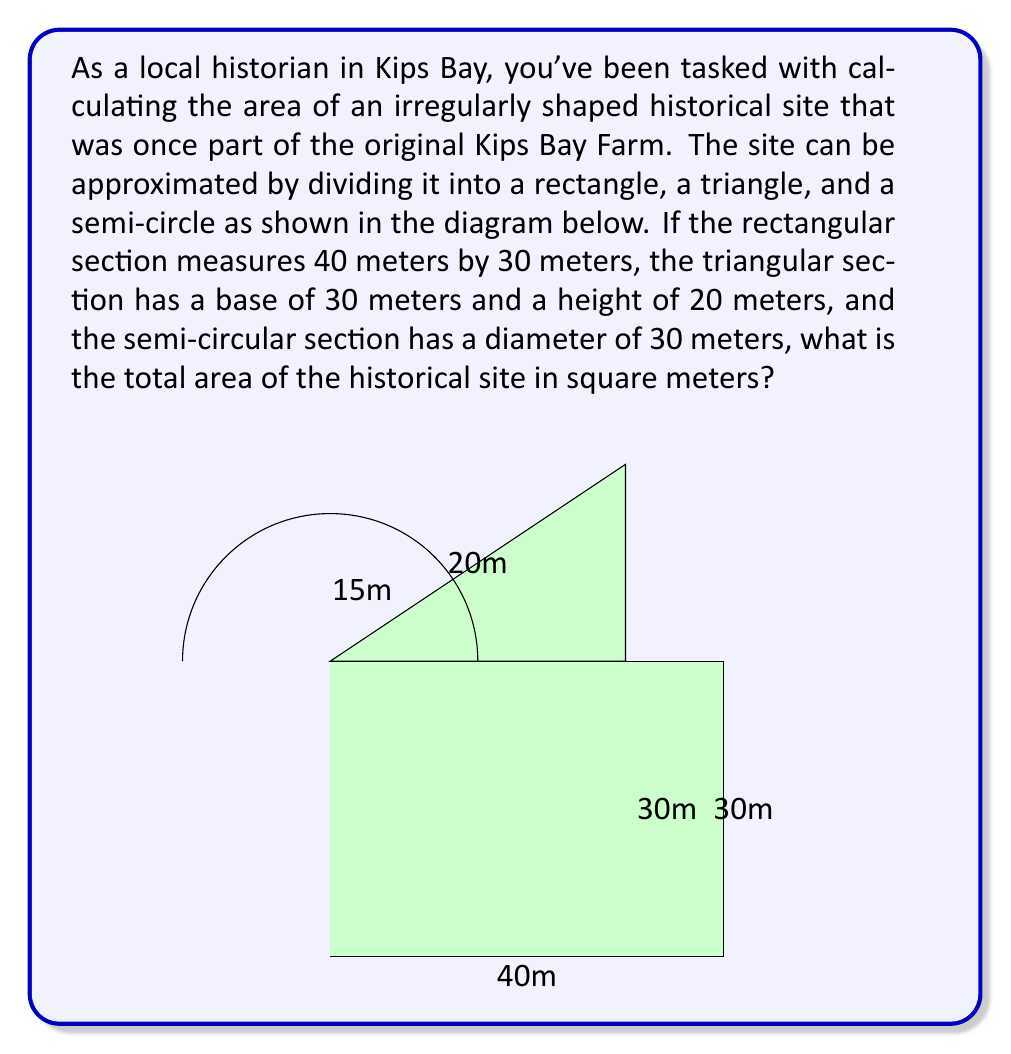What is the answer to this math problem? To solve this problem, we need to calculate the areas of each section and then sum them up:

1. Rectangle area:
   $A_{rectangle} = length \times width = 40 \text{ m} \times 30 \text{ m} = 1200 \text{ m}^2$

2. Triangle area:
   $A_{triangle} = \frac{1}{2} \times base \times height = \frac{1}{2} \times 30 \text{ m} \times 20 \text{ m} = 300 \text{ m}^2$

3. Semi-circle area:
   First, we need to calculate the radius, which is half the diameter:
   $r = \frac{30 \text{ m}}{2} = 15 \text{ m}$
   
   Now we can calculate the area:
   $A_{semi-circle} = \frac{1}{2} \times \pi r^2 = \frac{1}{2} \times \pi \times (15 \text{ m})^2 = \frac{450\pi}{2} \text{ m}^2 = 225\pi \text{ m}^2$

4. Total area:
   $A_{total} = A_{rectangle} + A_{triangle} + A_{semi-circle}$
   $A_{total} = 1200 \text{ m}^2 + 300 \text{ m}^2 + 225\pi \text{ m}^2$
   $A_{total} = 1500 + 225\pi \text{ m}^2$

To get a numerical value, we can use $\pi \approx 3.14159$:
$A_{total} \approx 1500 + 225 \times 3.14159 \text{ m}^2 \approx 2206.86 \text{ m}^2$
Answer: The total area of the historical site is $1500 + 225\pi \text{ m}^2$ or approximately $2206.86 \text{ m}^2$. 